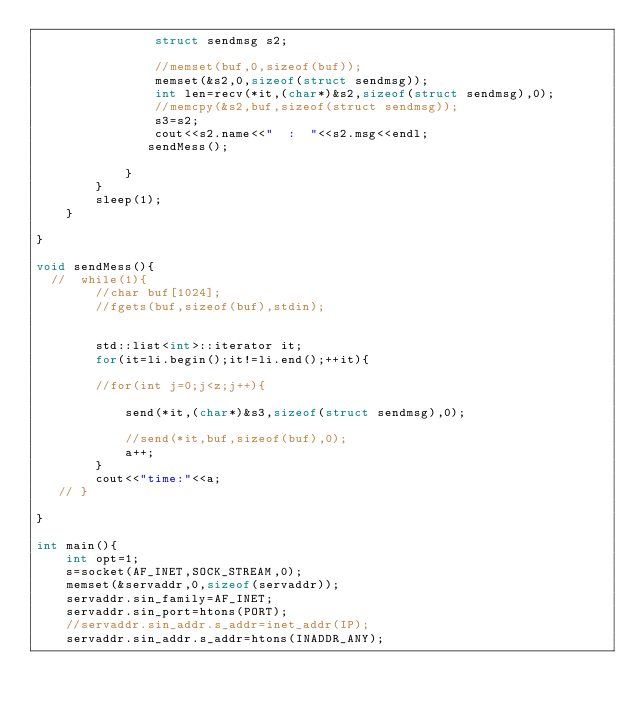Convert code to text. <code><loc_0><loc_0><loc_500><loc_500><_C++_>                struct sendmsg s2;
                
                //memset(buf,0,sizeof(buf));
                memset(&s2,0,sizeof(struct sendmsg));
                int len=recv(*it,(char*)&s2,sizeof(struct sendmsg),0);
                //memcpy(&s2,buf,sizeof(struct sendmsg));
                s3=s2;
                cout<<s2.name<<"  :  "<<s2.msg<<endl;
               sendMess(); 

            }
        }
        sleep(1);
    }
    
}

void sendMess(){
  //  while(1){
        //char buf[1024];
        //fgets(buf,sizeof(buf),stdin);
        

        std::list<int>::iterator it;
        for(it=li.begin();it!=li.end();++it){

        //for(int j=0;j<z;j++){

            send(*it,(char*)&s3,sizeof(struct sendmsg),0);

            //send(*it,buf,sizeof(buf),0);
            a++;
        }
        cout<<"time:"<<a;
   // }

}

int main(){
    int opt=1;
    s=socket(AF_INET,SOCK_STREAM,0);
    memset(&servaddr,0,sizeof(servaddr));
    servaddr.sin_family=AF_INET;
    servaddr.sin_port=htons(PORT);
    //servaddr.sin_addr.s_addr=inet_addr(IP);
    servaddr.sin_addr.s_addr=htons(INADDR_ANY);</code> 